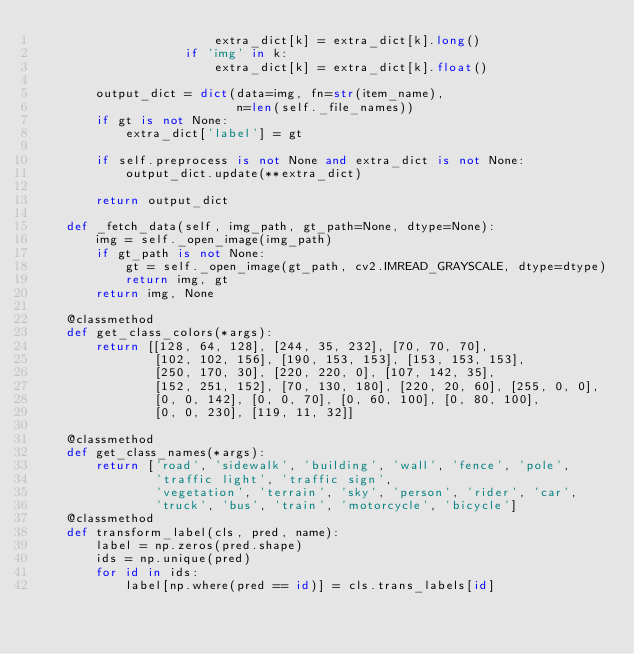Convert code to text. <code><loc_0><loc_0><loc_500><loc_500><_Python_>                        extra_dict[k] = extra_dict[k].long()
                    if 'img' in k:
                        extra_dict[k] = extra_dict[k].float()

        output_dict = dict(data=img, fn=str(item_name),
                           n=len(self._file_names))
        if gt is not None:
            extra_dict['label'] = gt

        if self.preprocess is not None and extra_dict is not None:
            output_dict.update(**extra_dict)

        return output_dict

    def _fetch_data(self, img_path, gt_path=None, dtype=None):
        img = self._open_image(img_path)
        if gt_path is not None:
            gt = self._open_image(gt_path, cv2.IMREAD_GRAYSCALE, dtype=dtype)
            return img, gt
        return img, None

    @classmethod
    def get_class_colors(*args):
        return [[128, 64, 128], [244, 35, 232], [70, 70, 70],
                [102, 102, 156], [190, 153, 153], [153, 153, 153],
                [250, 170, 30], [220, 220, 0], [107, 142, 35],
                [152, 251, 152], [70, 130, 180], [220, 20, 60], [255, 0, 0],
                [0, 0, 142], [0, 0, 70], [0, 60, 100], [0, 80, 100],
                [0, 0, 230], [119, 11, 32]]

    @classmethod
    def get_class_names(*args):
        return ['road', 'sidewalk', 'building', 'wall', 'fence', 'pole',
                'traffic light', 'traffic sign',
                'vegetation', 'terrain', 'sky', 'person', 'rider', 'car',
                'truck', 'bus', 'train', 'motorcycle', 'bicycle']
    @classmethod
    def transform_label(cls, pred, name):
        label = np.zeros(pred.shape)
        ids = np.unique(pred)
        for id in ids:
            label[np.where(pred == id)] = cls.trans_labels[id]
</code> 